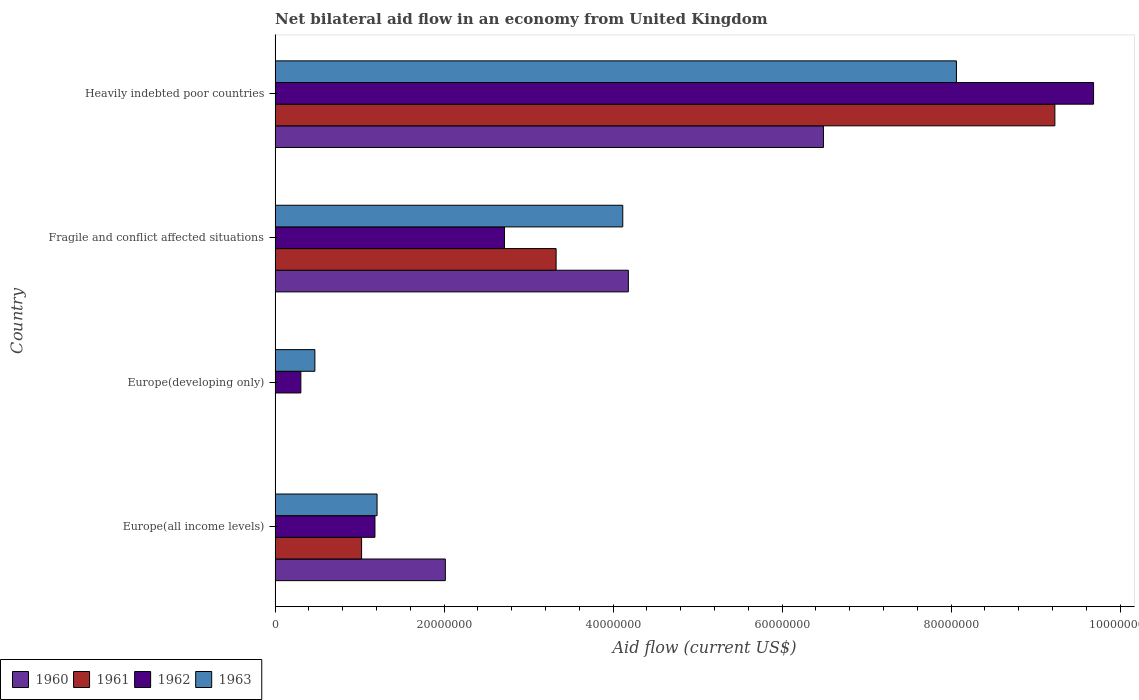How many different coloured bars are there?
Make the answer very short. 4. Are the number of bars per tick equal to the number of legend labels?
Offer a very short reply. No. Are the number of bars on each tick of the Y-axis equal?
Your answer should be compact. No. How many bars are there on the 3rd tick from the bottom?
Offer a terse response. 4. What is the label of the 2nd group of bars from the top?
Provide a succinct answer. Fragile and conflict affected situations. In how many cases, is the number of bars for a given country not equal to the number of legend labels?
Offer a terse response. 1. What is the net bilateral aid flow in 1963 in Fragile and conflict affected situations?
Offer a terse response. 4.12e+07. Across all countries, what is the maximum net bilateral aid flow in 1961?
Provide a short and direct response. 9.23e+07. Across all countries, what is the minimum net bilateral aid flow in 1961?
Offer a very short reply. 0. In which country was the net bilateral aid flow in 1961 maximum?
Make the answer very short. Heavily indebted poor countries. What is the total net bilateral aid flow in 1960 in the graph?
Your response must be concise. 1.27e+08. What is the difference between the net bilateral aid flow in 1960 in Europe(all income levels) and that in Heavily indebted poor countries?
Your answer should be compact. -4.48e+07. What is the difference between the net bilateral aid flow in 1963 in Europe(developing only) and the net bilateral aid flow in 1961 in Europe(all income levels)?
Your answer should be compact. -5.53e+06. What is the average net bilateral aid flow in 1963 per country?
Your answer should be compact. 3.46e+07. What is the difference between the net bilateral aid flow in 1963 and net bilateral aid flow in 1961 in Europe(all income levels)?
Keep it short and to the point. 1.83e+06. What is the ratio of the net bilateral aid flow in 1961 in Europe(all income levels) to that in Fragile and conflict affected situations?
Offer a terse response. 0.31. Is the difference between the net bilateral aid flow in 1963 in Europe(all income levels) and Fragile and conflict affected situations greater than the difference between the net bilateral aid flow in 1961 in Europe(all income levels) and Fragile and conflict affected situations?
Keep it short and to the point. No. What is the difference between the highest and the second highest net bilateral aid flow in 1961?
Keep it short and to the point. 5.90e+07. What is the difference between the highest and the lowest net bilateral aid flow in 1961?
Your answer should be very brief. 9.23e+07. In how many countries, is the net bilateral aid flow in 1961 greater than the average net bilateral aid flow in 1961 taken over all countries?
Your answer should be very brief. 1. How many countries are there in the graph?
Your answer should be compact. 4. Does the graph contain grids?
Make the answer very short. No. Where does the legend appear in the graph?
Your response must be concise. Bottom left. How many legend labels are there?
Your answer should be compact. 4. How are the legend labels stacked?
Offer a very short reply. Horizontal. What is the title of the graph?
Keep it short and to the point. Net bilateral aid flow in an economy from United Kingdom. Does "1972" appear as one of the legend labels in the graph?
Offer a very short reply. No. What is the label or title of the X-axis?
Provide a short and direct response. Aid flow (current US$). What is the label or title of the Y-axis?
Offer a terse response. Country. What is the Aid flow (current US$) in 1960 in Europe(all income levels)?
Your answer should be compact. 2.02e+07. What is the Aid flow (current US$) in 1961 in Europe(all income levels)?
Provide a succinct answer. 1.02e+07. What is the Aid flow (current US$) in 1962 in Europe(all income levels)?
Ensure brevity in your answer.  1.18e+07. What is the Aid flow (current US$) of 1963 in Europe(all income levels)?
Keep it short and to the point. 1.21e+07. What is the Aid flow (current US$) of 1960 in Europe(developing only)?
Offer a very short reply. 0. What is the Aid flow (current US$) of 1962 in Europe(developing only)?
Ensure brevity in your answer.  3.05e+06. What is the Aid flow (current US$) in 1963 in Europe(developing only)?
Make the answer very short. 4.71e+06. What is the Aid flow (current US$) in 1960 in Fragile and conflict affected situations?
Ensure brevity in your answer.  4.18e+07. What is the Aid flow (current US$) in 1961 in Fragile and conflict affected situations?
Ensure brevity in your answer.  3.33e+07. What is the Aid flow (current US$) in 1962 in Fragile and conflict affected situations?
Offer a very short reply. 2.72e+07. What is the Aid flow (current US$) in 1963 in Fragile and conflict affected situations?
Provide a short and direct response. 4.12e+07. What is the Aid flow (current US$) of 1960 in Heavily indebted poor countries?
Make the answer very short. 6.49e+07. What is the Aid flow (current US$) in 1961 in Heavily indebted poor countries?
Ensure brevity in your answer.  9.23e+07. What is the Aid flow (current US$) in 1962 in Heavily indebted poor countries?
Give a very brief answer. 9.69e+07. What is the Aid flow (current US$) in 1963 in Heavily indebted poor countries?
Give a very brief answer. 8.06e+07. Across all countries, what is the maximum Aid flow (current US$) of 1960?
Make the answer very short. 6.49e+07. Across all countries, what is the maximum Aid flow (current US$) of 1961?
Your response must be concise. 9.23e+07. Across all countries, what is the maximum Aid flow (current US$) of 1962?
Ensure brevity in your answer.  9.69e+07. Across all countries, what is the maximum Aid flow (current US$) of 1963?
Offer a very short reply. 8.06e+07. Across all countries, what is the minimum Aid flow (current US$) of 1961?
Your answer should be compact. 0. Across all countries, what is the minimum Aid flow (current US$) of 1962?
Provide a succinct answer. 3.05e+06. Across all countries, what is the minimum Aid flow (current US$) in 1963?
Keep it short and to the point. 4.71e+06. What is the total Aid flow (current US$) in 1960 in the graph?
Keep it short and to the point. 1.27e+08. What is the total Aid flow (current US$) in 1961 in the graph?
Provide a succinct answer. 1.36e+08. What is the total Aid flow (current US$) of 1962 in the graph?
Your answer should be compact. 1.39e+08. What is the total Aid flow (current US$) of 1963 in the graph?
Provide a short and direct response. 1.39e+08. What is the difference between the Aid flow (current US$) in 1962 in Europe(all income levels) and that in Europe(developing only)?
Your response must be concise. 8.77e+06. What is the difference between the Aid flow (current US$) in 1963 in Europe(all income levels) and that in Europe(developing only)?
Your answer should be very brief. 7.36e+06. What is the difference between the Aid flow (current US$) of 1960 in Europe(all income levels) and that in Fragile and conflict affected situations?
Offer a very short reply. -2.17e+07. What is the difference between the Aid flow (current US$) of 1961 in Europe(all income levels) and that in Fragile and conflict affected situations?
Offer a very short reply. -2.30e+07. What is the difference between the Aid flow (current US$) in 1962 in Europe(all income levels) and that in Fragile and conflict affected situations?
Provide a succinct answer. -1.53e+07. What is the difference between the Aid flow (current US$) of 1963 in Europe(all income levels) and that in Fragile and conflict affected situations?
Give a very brief answer. -2.91e+07. What is the difference between the Aid flow (current US$) in 1960 in Europe(all income levels) and that in Heavily indebted poor countries?
Provide a short and direct response. -4.48e+07. What is the difference between the Aid flow (current US$) in 1961 in Europe(all income levels) and that in Heavily indebted poor countries?
Make the answer very short. -8.20e+07. What is the difference between the Aid flow (current US$) of 1962 in Europe(all income levels) and that in Heavily indebted poor countries?
Your response must be concise. -8.50e+07. What is the difference between the Aid flow (current US$) in 1963 in Europe(all income levels) and that in Heavily indebted poor countries?
Give a very brief answer. -6.86e+07. What is the difference between the Aid flow (current US$) in 1962 in Europe(developing only) and that in Fragile and conflict affected situations?
Your response must be concise. -2.41e+07. What is the difference between the Aid flow (current US$) in 1963 in Europe(developing only) and that in Fragile and conflict affected situations?
Give a very brief answer. -3.64e+07. What is the difference between the Aid flow (current US$) in 1962 in Europe(developing only) and that in Heavily indebted poor countries?
Ensure brevity in your answer.  -9.38e+07. What is the difference between the Aid flow (current US$) in 1963 in Europe(developing only) and that in Heavily indebted poor countries?
Ensure brevity in your answer.  -7.59e+07. What is the difference between the Aid flow (current US$) in 1960 in Fragile and conflict affected situations and that in Heavily indebted poor countries?
Your response must be concise. -2.31e+07. What is the difference between the Aid flow (current US$) of 1961 in Fragile and conflict affected situations and that in Heavily indebted poor countries?
Your answer should be compact. -5.90e+07. What is the difference between the Aid flow (current US$) of 1962 in Fragile and conflict affected situations and that in Heavily indebted poor countries?
Give a very brief answer. -6.97e+07. What is the difference between the Aid flow (current US$) in 1963 in Fragile and conflict affected situations and that in Heavily indebted poor countries?
Offer a terse response. -3.95e+07. What is the difference between the Aid flow (current US$) in 1960 in Europe(all income levels) and the Aid flow (current US$) in 1962 in Europe(developing only)?
Give a very brief answer. 1.71e+07. What is the difference between the Aid flow (current US$) in 1960 in Europe(all income levels) and the Aid flow (current US$) in 1963 in Europe(developing only)?
Provide a succinct answer. 1.54e+07. What is the difference between the Aid flow (current US$) in 1961 in Europe(all income levels) and the Aid flow (current US$) in 1962 in Europe(developing only)?
Offer a terse response. 7.19e+06. What is the difference between the Aid flow (current US$) of 1961 in Europe(all income levels) and the Aid flow (current US$) of 1963 in Europe(developing only)?
Offer a terse response. 5.53e+06. What is the difference between the Aid flow (current US$) of 1962 in Europe(all income levels) and the Aid flow (current US$) of 1963 in Europe(developing only)?
Your answer should be very brief. 7.11e+06. What is the difference between the Aid flow (current US$) of 1960 in Europe(all income levels) and the Aid flow (current US$) of 1961 in Fragile and conflict affected situations?
Your answer should be compact. -1.31e+07. What is the difference between the Aid flow (current US$) of 1960 in Europe(all income levels) and the Aid flow (current US$) of 1962 in Fragile and conflict affected situations?
Offer a very short reply. -7.00e+06. What is the difference between the Aid flow (current US$) in 1960 in Europe(all income levels) and the Aid flow (current US$) in 1963 in Fragile and conflict affected situations?
Make the answer very short. -2.10e+07. What is the difference between the Aid flow (current US$) in 1961 in Europe(all income levels) and the Aid flow (current US$) in 1962 in Fragile and conflict affected situations?
Keep it short and to the point. -1.69e+07. What is the difference between the Aid flow (current US$) of 1961 in Europe(all income levels) and the Aid flow (current US$) of 1963 in Fragile and conflict affected situations?
Make the answer very short. -3.09e+07. What is the difference between the Aid flow (current US$) in 1962 in Europe(all income levels) and the Aid flow (current US$) in 1963 in Fragile and conflict affected situations?
Provide a short and direct response. -2.93e+07. What is the difference between the Aid flow (current US$) in 1960 in Europe(all income levels) and the Aid flow (current US$) in 1961 in Heavily indebted poor countries?
Keep it short and to the point. -7.21e+07. What is the difference between the Aid flow (current US$) in 1960 in Europe(all income levels) and the Aid flow (current US$) in 1962 in Heavily indebted poor countries?
Your answer should be very brief. -7.67e+07. What is the difference between the Aid flow (current US$) in 1960 in Europe(all income levels) and the Aid flow (current US$) in 1963 in Heavily indebted poor countries?
Make the answer very short. -6.05e+07. What is the difference between the Aid flow (current US$) of 1961 in Europe(all income levels) and the Aid flow (current US$) of 1962 in Heavily indebted poor countries?
Provide a short and direct response. -8.66e+07. What is the difference between the Aid flow (current US$) in 1961 in Europe(all income levels) and the Aid flow (current US$) in 1963 in Heavily indebted poor countries?
Provide a succinct answer. -7.04e+07. What is the difference between the Aid flow (current US$) of 1962 in Europe(all income levels) and the Aid flow (current US$) of 1963 in Heavily indebted poor countries?
Your answer should be compact. -6.88e+07. What is the difference between the Aid flow (current US$) in 1962 in Europe(developing only) and the Aid flow (current US$) in 1963 in Fragile and conflict affected situations?
Provide a succinct answer. -3.81e+07. What is the difference between the Aid flow (current US$) of 1962 in Europe(developing only) and the Aid flow (current US$) of 1963 in Heavily indebted poor countries?
Provide a succinct answer. -7.76e+07. What is the difference between the Aid flow (current US$) in 1960 in Fragile and conflict affected situations and the Aid flow (current US$) in 1961 in Heavily indebted poor countries?
Offer a very short reply. -5.05e+07. What is the difference between the Aid flow (current US$) in 1960 in Fragile and conflict affected situations and the Aid flow (current US$) in 1962 in Heavily indebted poor countries?
Offer a very short reply. -5.51e+07. What is the difference between the Aid flow (current US$) of 1960 in Fragile and conflict affected situations and the Aid flow (current US$) of 1963 in Heavily indebted poor countries?
Offer a terse response. -3.88e+07. What is the difference between the Aid flow (current US$) in 1961 in Fragile and conflict affected situations and the Aid flow (current US$) in 1962 in Heavily indebted poor countries?
Give a very brief answer. -6.36e+07. What is the difference between the Aid flow (current US$) of 1961 in Fragile and conflict affected situations and the Aid flow (current US$) of 1963 in Heavily indebted poor countries?
Provide a succinct answer. -4.74e+07. What is the difference between the Aid flow (current US$) in 1962 in Fragile and conflict affected situations and the Aid flow (current US$) in 1963 in Heavily indebted poor countries?
Offer a terse response. -5.35e+07. What is the average Aid flow (current US$) of 1960 per country?
Provide a short and direct response. 3.17e+07. What is the average Aid flow (current US$) of 1961 per country?
Your answer should be compact. 3.39e+07. What is the average Aid flow (current US$) of 1962 per country?
Your response must be concise. 3.47e+07. What is the average Aid flow (current US$) in 1963 per country?
Your answer should be compact. 3.46e+07. What is the difference between the Aid flow (current US$) of 1960 and Aid flow (current US$) of 1961 in Europe(all income levels)?
Your answer should be very brief. 9.91e+06. What is the difference between the Aid flow (current US$) in 1960 and Aid flow (current US$) in 1962 in Europe(all income levels)?
Your answer should be very brief. 8.33e+06. What is the difference between the Aid flow (current US$) in 1960 and Aid flow (current US$) in 1963 in Europe(all income levels)?
Give a very brief answer. 8.08e+06. What is the difference between the Aid flow (current US$) in 1961 and Aid flow (current US$) in 1962 in Europe(all income levels)?
Give a very brief answer. -1.58e+06. What is the difference between the Aid flow (current US$) of 1961 and Aid flow (current US$) of 1963 in Europe(all income levels)?
Ensure brevity in your answer.  -1.83e+06. What is the difference between the Aid flow (current US$) of 1962 and Aid flow (current US$) of 1963 in Europe(all income levels)?
Your answer should be compact. -2.50e+05. What is the difference between the Aid flow (current US$) of 1962 and Aid flow (current US$) of 1963 in Europe(developing only)?
Offer a very short reply. -1.66e+06. What is the difference between the Aid flow (current US$) in 1960 and Aid flow (current US$) in 1961 in Fragile and conflict affected situations?
Give a very brief answer. 8.55e+06. What is the difference between the Aid flow (current US$) in 1960 and Aid flow (current US$) in 1962 in Fragile and conflict affected situations?
Keep it short and to the point. 1.47e+07. What is the difference between the Aid flow (current US$) of 1961 and Aid flow (current US$) of 1962 in Fragile and conflict affected situations?
Ensure brevity in your answer.  6.11e+06. What is the difference between the Aid flow (current US$) of 1961 and Aid flow (current US$) of 1963 in Fragile and conflict affected situations?
Provide a short and direct response. -7.89e+06. What is the difference between the Aid flow (current US$) in 1962 and Aid flow (current US$) in 1963 in Fragile and conflict affected situations?
Give a very brief answer. -1.40e+07. What is the difference between the Aid flow (current US$) in 1960 and Aid flow (current US$) in 1961 in Heavily indebted poor countries?
Your response must be concise. -2.74e+07. What is the difference between the Aid flow (current US$) in 1960 and Aid flow (current US$) in 1962 in Heavily indebted poor countries?
Provide a short and direct response. -3.20e+07. What is the difference between the Aid flow (current US$) of 1960 and Aid flow (current US$) of 1963 in Heavily indebted poor countries?
Your answer should be compact. -1.57e+07. What is the difference between the Aid flow (current US$) of 1961 and Aid flow (current US$) of 1962 in Heavily indebted poor countries?
Your answer should be very brief. -4.58e+06. What is the difference between the Aid flow (current US$) in 1961 and Aid flow (current US$) in 1963 in Heavily indebted poor countries?
Your answer should be compact. 1.16e+07. What is the difference between the Aid flow (current US$) of 1962 and Aid flow (current US$) of 1963 in Heavily indebted poor countries?
Provide a short and direct response. 1.62e+07. What is the ratio of the Aid flow (current US$) of 1962 in Europe(all income levels) to that in Europe(developing only)?
Make the answer very short. 3.88. What is the ratio of the Aid flow (current US$) in 1963 in Europe(all income levels) to that in Europe(developing only)?
Provide a succinct answer. 2.56. What is the ratio of the Aid flow (current US$) of 1960 in Europe(all income levels) to that in Fragile and conflict affected situations?
Your answer should be very brief. 0.48. What is the ratio of the Aid flow (current US$) in 1961 in Europe(all income levels) to that in Fragile and conflict affected situations?
Keep it short and to the point. 0.31. What is the ratio of the Aid flow (current US$) of 1962 in Europe(all income levels) to that in Fragile and conflict affected situations?
Provide a short and direct response. 0.44. What is the ratio of the Aid flow (current US$) in 1963 in Europe(all income levels) to that in Fragile and conflict affected situations?
Give a very brief answer. 0.29. What is the ratio of the Aid flow (current US$) of 1960 in Europe(all income levels) to that in Heavily indebted poor countries?
Offer a terse response. 0.31. What is the ratio of the Aid flow (current US$) in 1961 in Europe(all income levels) to that in Heavily indebted poor countries?
Your answer should be compact. 0.11. What is the ratio of the Aid flow (current US$) in 1962 in Europe(all income levels) to that in Heavily indebted poor countries?
Provide a succinct answer. 0.12. What is the ratio of the Aid flow (current US$) in 1963 in Europe(all income levels) to that in Heavily indebted poor countries?
Provide a short and direct response. 0.15. What is the ratio of the Aid flow (current US$) of 1962 in Europe(developing only) to that in Fragile and conflict affected situations?
Offer a terse response. 0.11. What is the ratio of the Aid flow (current US$) of 1963 in Europe(developing only) to that in Fragile and conflict affected situations?
Your answer should be very brief. 0.11. What is the ratio of the Aid flow (current US$) in 1962 in Europe(developing only) to that in Heavily indebted poor countries?
Provide a succinct answer. 0.03. What is the ratio of the Aid flow (current US$) of 1963 in Europe(developing only) to that in Heavily indebted poor countries?
Give a very brief answer. 0.06. What is the ratio of the Aid flow (current US$) in 1960 in Fragile and conflict affected situations to that in Heavily indebted poor countries?
Make the answer very short. 0.64. What is the ratio of the Aid flow (current US$) in 1961 in Fragile and conflict affected situations to that in Heavily indebted poor countries?
Make the answer very short. 0.36. What is the ratio of the Aid flow (current US$) of 1962 in Fragile and conflict affected situations to that in Heavily indebted poor countries?
Your answer should be very brief. 0.28. What is the ratio of the Aid flow (current US$) in 1963 in Fragile and conflict affected situations to that in Heavily indebted poor countries?
Give a very brief answer. 0.51. What is the difference between the highest and the second highest Aid flow (current US$) in 1960?
Make the answer very short. 2.31e+07. What is the difference between the highest and the second highest Aid flow (current US$) of 1961?
Keep it short and to the point. 5.90e+07. What is the difference between the highest and the second highest Aid flow (current US$) of 1962?
Provide a short and direct response. 6.97e+07. What is the difference between the highest and the second highest Aid flow (current US$) in 1963?
Your response must be concise. 3.95e+07. What is the difference between the highest and the lowest Aid flow (current US$) in 1960?
Ensure brevity in your answer.  6.49e+07. What is the difference between the highest and the lowest Aid flow (current US$) in 1961?
Make the answer very short. 9.23e+07. What is the difference between the highest and the lowest Aid flow (current US$) in 1962?
Your answer should be very brief. 9.38e+07. What is the difference between the highest and the lowest Aid flow (current US$) in 1963?
Your response must be concise. 7.59e+07. 